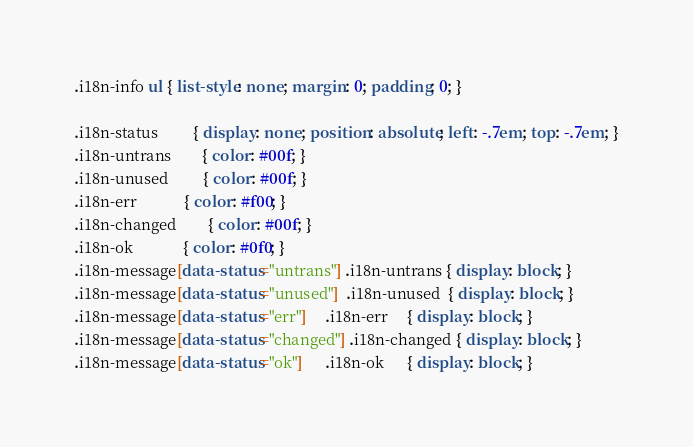<code> <loc_0><loc_0><loc_500><loc_500><_CSS_>.i18n-info ul { list-style: none; margin: 0; padding: 0; }

.i18n-status         { display: none; position: absolute; left: -.7em; top: -.7em; }
.i18n-untrans        { color: #00f; }
.i18n-unused         { color: #00f; }
.i18n-err            { color: #f00; }
.i18n-changed        { color: #00f; }
.i18n-ok             { color: #0f0; }
.i18n-message[data-status="untrans"] .i18n-untrans { display: block; }
.i18n-message[data-status="unused"]  .i18n-unused  { display: block; }
.i18n-message[data-status="err"]     .i18n-err     { display: block; }
.i18n-message[data-status="changed"] .i18n-changed { display: block; }
.i18n-message[data-status="ok"]      .i18n-ok      { display: block; }
</code> 